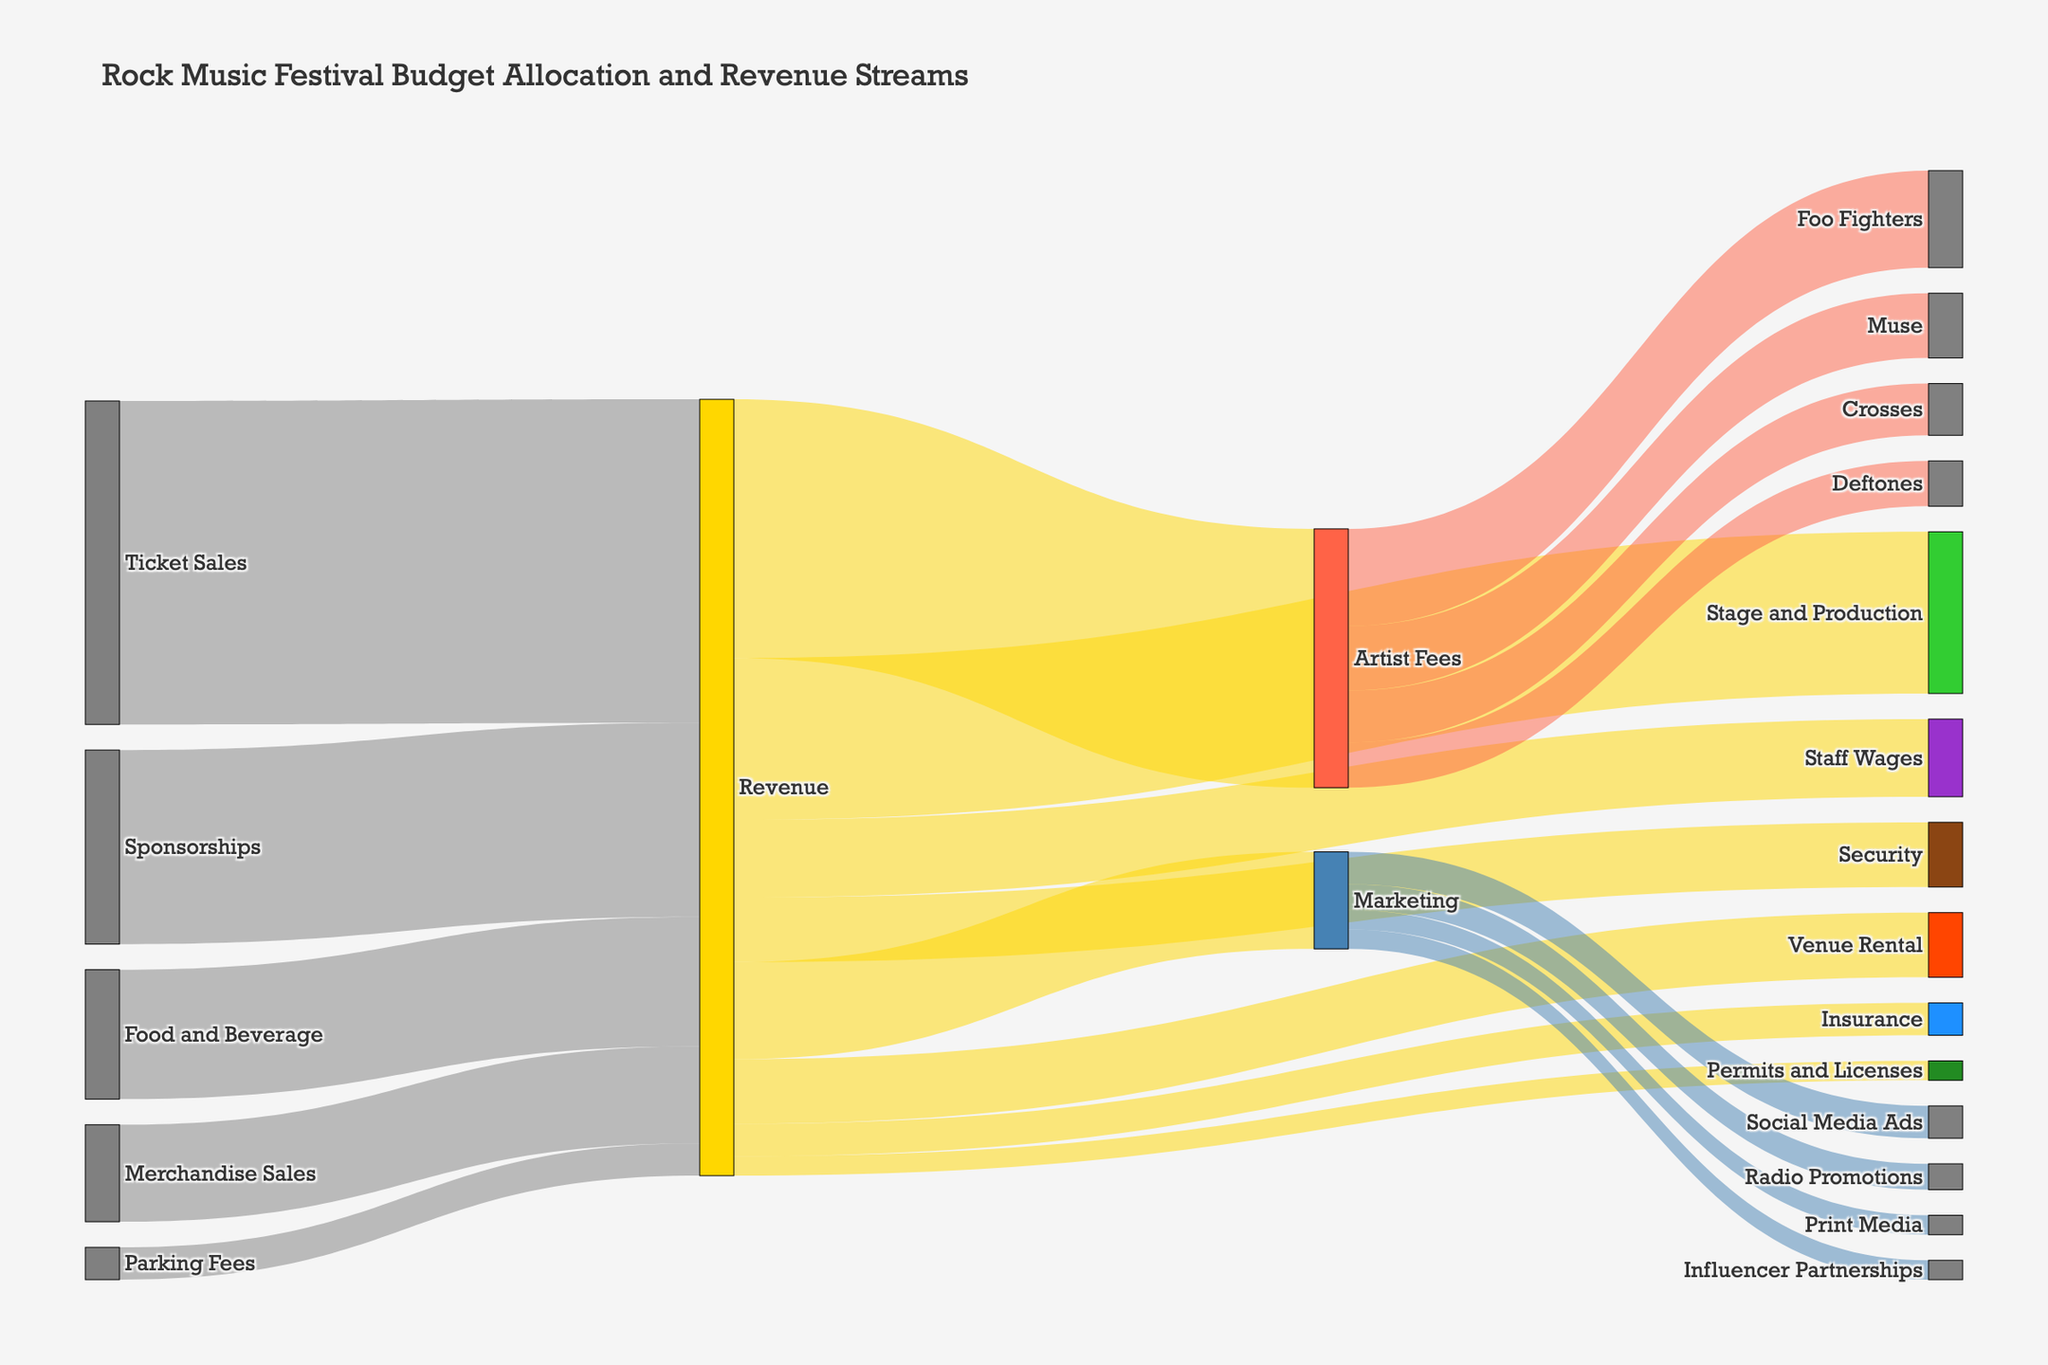what is the total revenue from Ticket Sales? The figure shows that Ticket Sales contribute 500,000 to the Revenue stream.
Answer: 500,000 which expense has the highest allocation from the Revenue? From the figure, Artist Fees have the highest allocation, receiving 400,000 from the Revenue.
Answer: Artist Fees how many different sources contribute to the Revenue? The Sankey diagram depicts five sources contributing to the Revenue: Ticket Sales, Sponsorships, Merchandise Sales, Food and Beverage, and Parking Fees.
Answer: 5 what is the main target of the Artist Fees? The Sankey diagram shows Artist Fees being allocated to four artists: Crosses, Deftones, Muse, and Foo Fighters. Among these, Foo Fighters have the highest allocation of 150,000.
Answer: Foo Fighters which marketing channel receives the least allocation from Marketing funds? The figure indicates that Print Media and Influencer Partnerships each receive the least allocation from Marketing, both getting 30,000.
Answer: Print Media and Influencer Partnerships what is the combined allocation for Security and Staff Wages? From the diagram, Security receives 100,000 and Staff Wages receive 120,000. Their combined allocation is 100,000 + 120,000 = 220,000.
Answer: 220,000 how does Insurance allocation compare to Permits and Licenses allocation? The Sankey diagram shows that Insurance receives 50,000 and Permits and Licenses receive 30,000. Thus, Insurance allocation is higher.
Answer: Insurance allocation is higher what percentage of Revenue is allocated to Venue Rental? Venue Rental receives 100,000 from the Revenue of 1,200,000 (the sum of all revenue streams: 500,000 + 300,000 + 150,000 + 200,000 + 50,000). The percentage is (100,000 / 1,200,000) * 100 ≈ 8.33%.
Answer: 8.33% what proportion of Marketing funds is allocated to Social Media Ads? Social Media Ads receive 50,000 out of the total Marketing budget of 150,000. The proportion is 50,000 / 150,000 = 1/3.
Answer: 1/3 which expenses receive equal allocations from the Revenue? According to the diagram, Venue Rental and Security each receive 100,000 from the Revenue.
Answer: Venue Rental and Security 